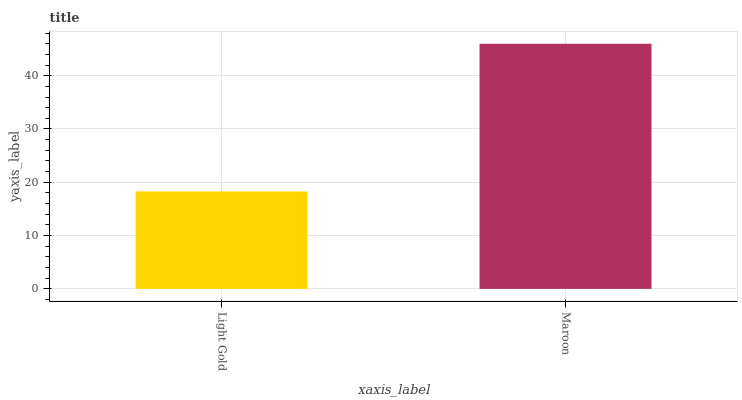Is Maroon the minimum?
Answer yes or no. No. Is Maroon greater than Light Gold?
Answer yes or no. Yes. Is Light Gold less than Maroon?
Answer yes or no. Yes. Is Light Gold greater than Maroon?
Answer yes or no. No. Is Maroon less than Light Gold?
Answer yes or no. No. Is Maroon the high median?
Answer yes or no. Yes. Is Light Gold the low median?
Answer yes or no. Yes. Is Light Gold the high median?
Answer yes or no. No. Is Maroon the low median?
Answer yes or no. No. 